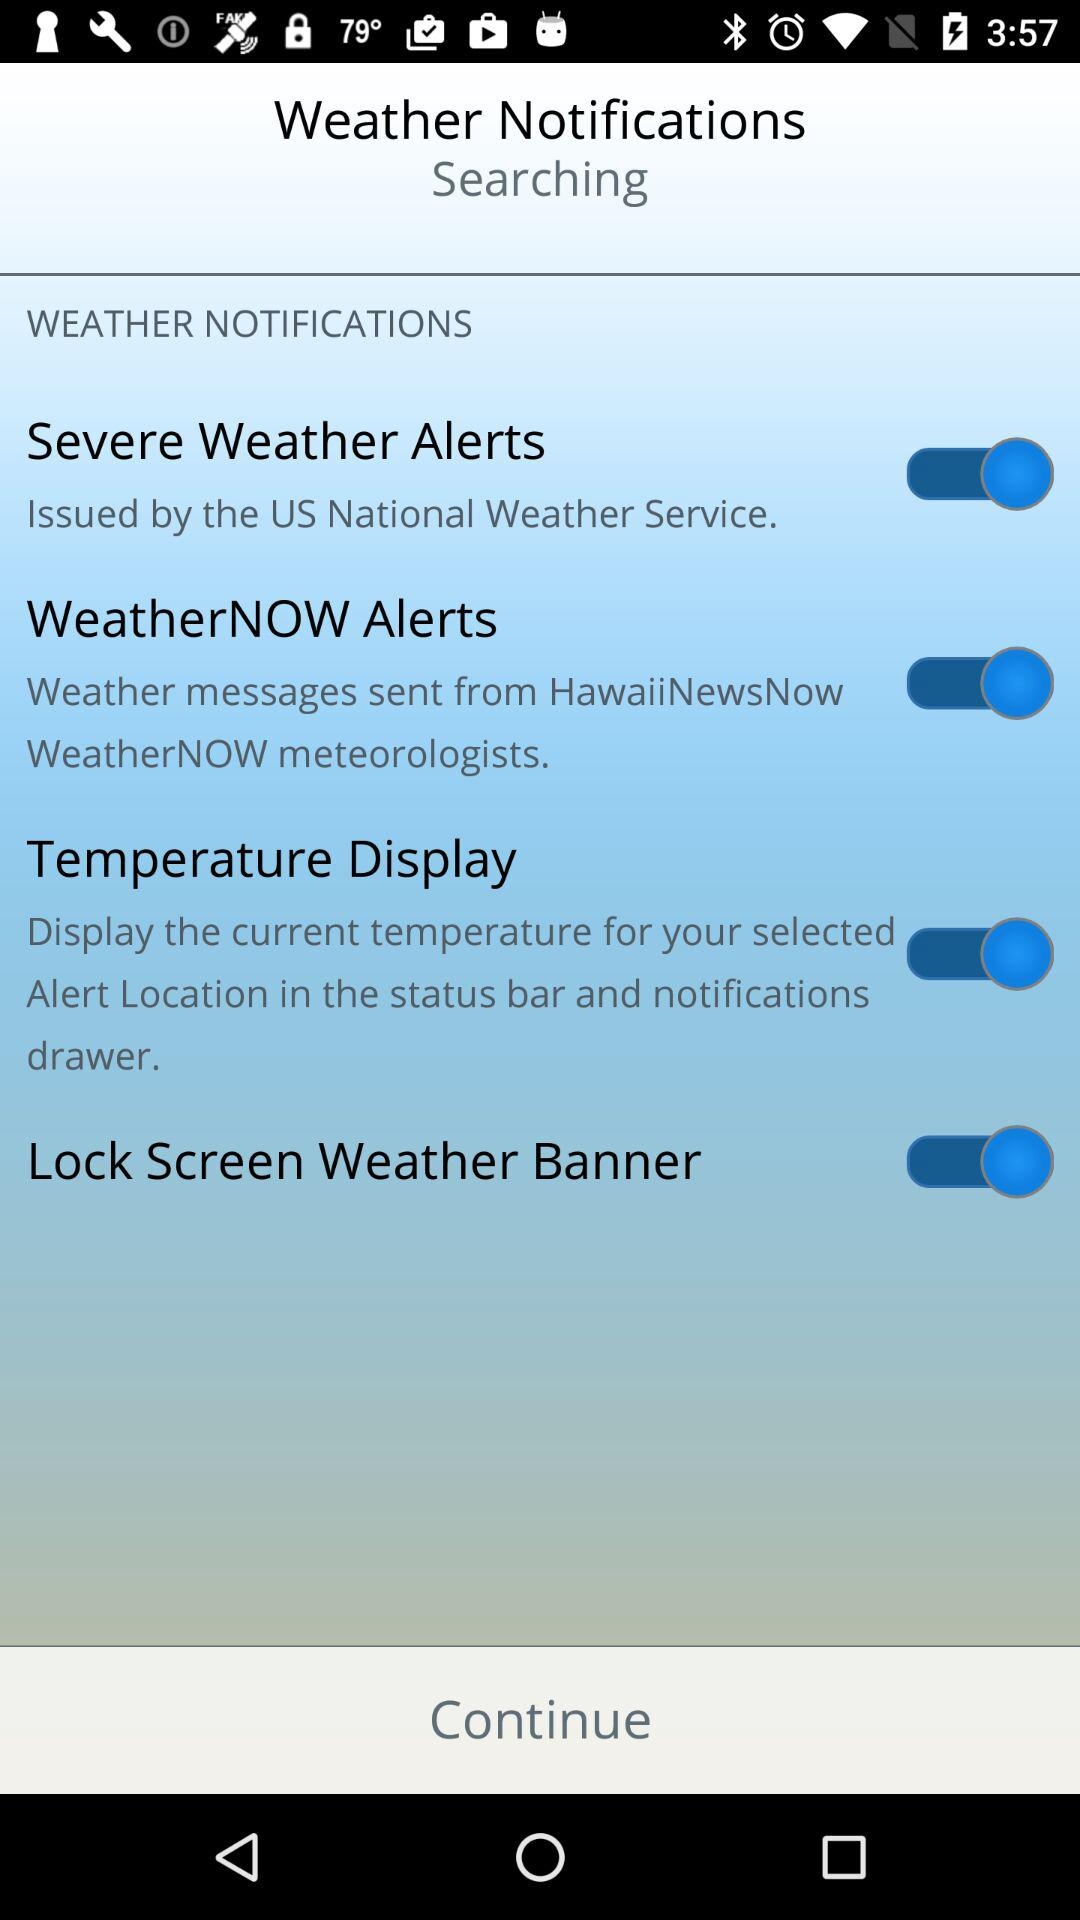By what agency were severe weather alerts issued? Severe weather alerts were issued by the "US National Weather Service". 